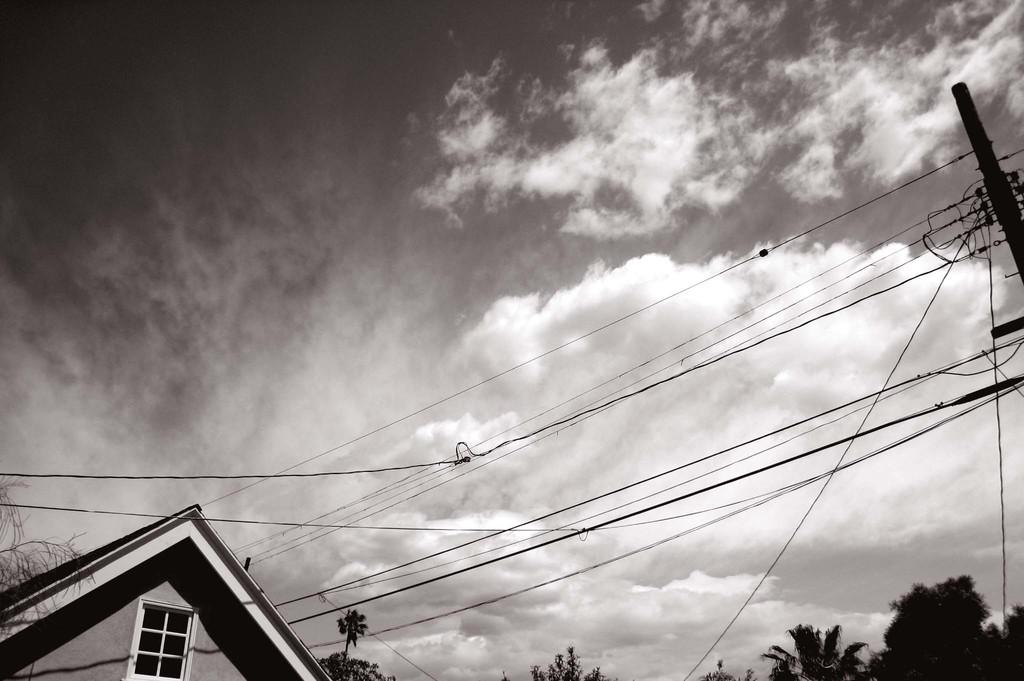What is the color scheme of the image? The image is black and white. What structure can be seen in the image? There is a house in the image. What other object is present in the image? There is an electric pole in the image. What can be seen in the background of the image? There are trees and the sky visible in the background of the image. What type of brush is being used to paint the house in the image? There is no brush or painting activity depicted in the image; it is a black and white photograph. Can you tell me how many shocks the electric pole is giving off in the image? There is no indication of any electrical issues or shocks in the image; the electric pole is simply a part of the scene. 